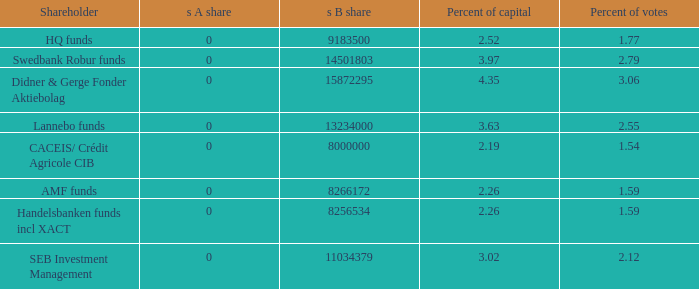What is the percent of capital for the shareholder that has a s B share of 8256534?  2.26. 